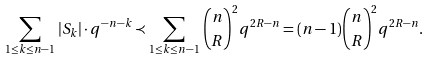Convert formula to latex. <formula><loc_0><loc_0><loc_500><loc_500>\sum _ { 1 \leq k \leq n - 1 } \, | S _ { k } | \cdot q ^ { - n - k } \prec \sum _ { 1 \leq k \leq n - 1 } \, \binom { n } { R } ^ { 2 } q ^ { 2 R - n } = ( n - 1 ) \binom { n } { R } ^ { 2 } q ^ { 2 R - n } .</formula> 